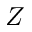Convert formula to latex. <formula><loc_0><loc_0><loc_500><loc_500>Z</formula> 